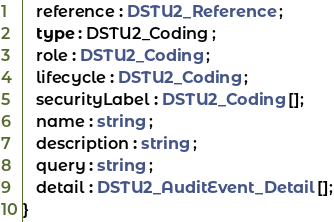Convert code to text. <code><loc_0><loc_0><loc_500><loc_500><_TypeScript_>   reference : DSTU2_Reference ;
   type : DSTU2_Coding ;
   role : DSTU2_Coding ;
   lifecycle : DSTU2_Coding ;
   securityLabel : DSTU2_Coding [];
   name : string ;
   description : string ;
   query : string ;
   detail : DSTU2_AuditEvent_Detail [];
}
</code> 